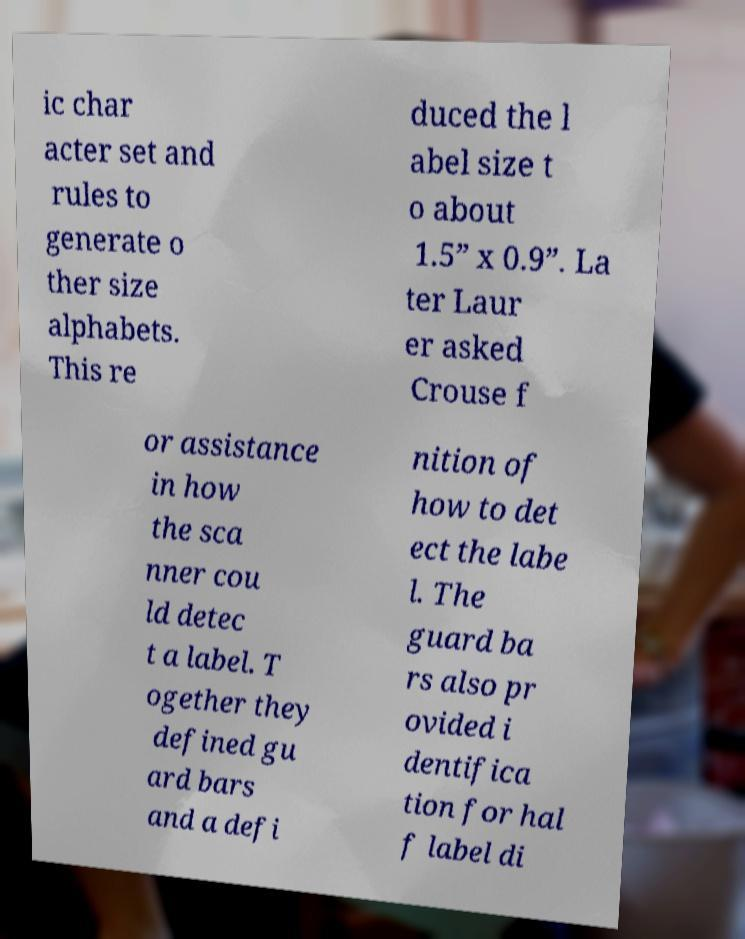Please identify and transcribe the text found in this image. ic char acter set and rules to generate o ther size alphabets. This re duced the l abel size t o about 1.5” x 0.9”. La ter Laur er asked Crouse f or assistance in how the sca nner cou ld detec t a label. T ogether they defined gu ard bars and a defi nition of how to det ect the labe l. The guard ba rs also pr ovided i dentifica tion for hal f label di 